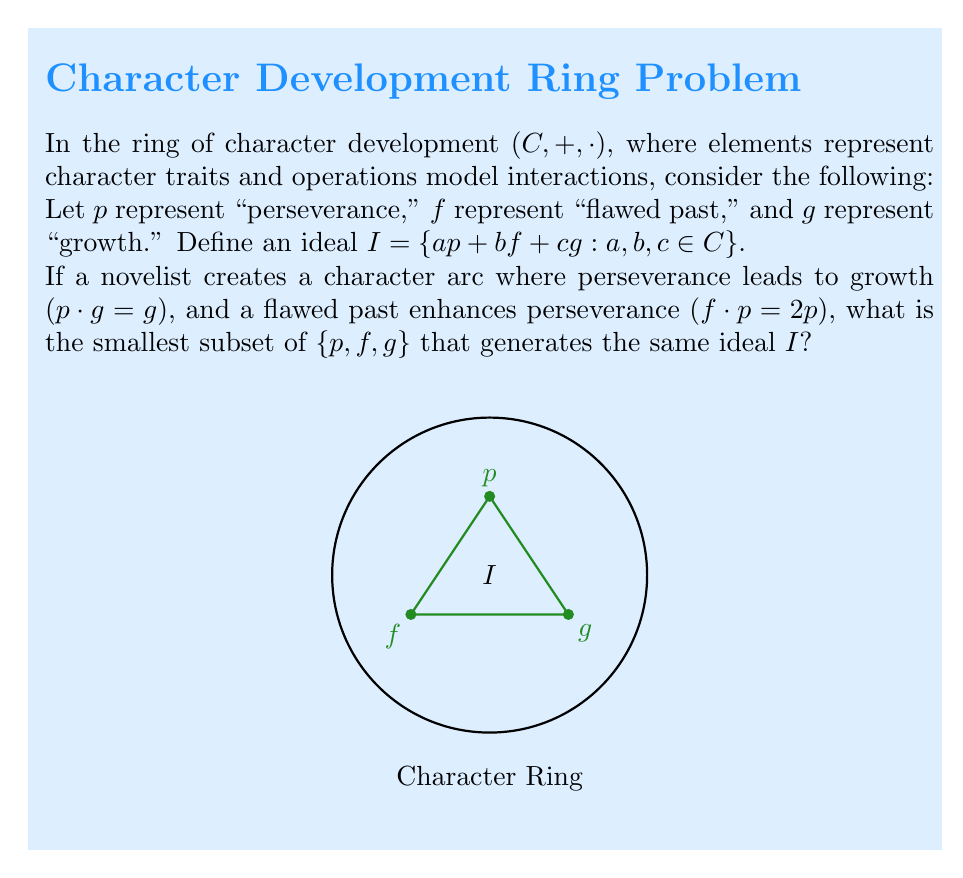Teach me how to tackle this problem. Let's approach this step-by-step:

1) First, we need to understand what it means for a subset to generate the same ideal. If a subset $S$ generates $I$, then every element in $I$ can be written as a linear combination of elements in $S$ and their products with ring elements.

2) Given the conditions:
   $p \cdot g = g$
   $f \cdot p = 2p$

3) Let's consider each element:

   a) $p$: Can generate itself.
   
   b) $f$: Can generate $2p$ through $f \cdot p = 2p$. This means $f$ can indirectly generate $p$.
   
   c) $g$: Can be generated by $p$ through $p \cdot g = g$.

4) From this, we can see that $f$ can generate $p$, and $p$ can generate $g$.

5) Therefore, the smallest subset that can generate all elements in $I$ is $\{f\}$.

6) To verify:
   - $f$ can generate $p$ : $f \cdot p = 2p$, so $p = \frac{1}{2}(f \cdot p)$
   - $f$ can then generate $g$ : $g = p \cdot g = (\frac{1}{2}(f \cdot p)) \cdot g$

7) Thus, any element in $I$ of the form $ap + bf + cg$ can be generated using only $f$.
Answer: $\{f\}$ 